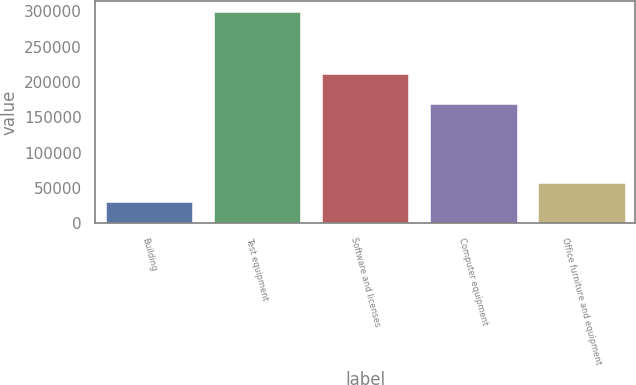Convert chart to OTSL. <chart><loc_0><loc_0><loc_500><loc_500><bar_chart><fcel>Building<fcel>Test equipment<fcel>Software and licenses<fcel>Computer equipment<fcel>Office furniture and equipment<nl><fcel>30869<fcel>299506<fcel>211339<fcel>168455<fcel>57732.7<nl></chart> 